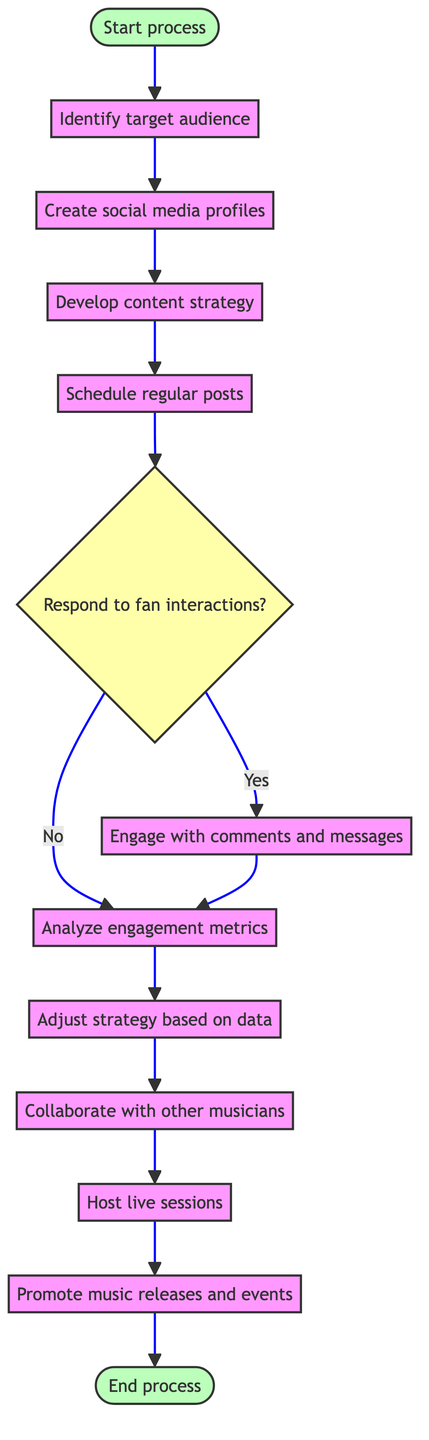What is the first action in the diagram? The first action after the start node is "Identify target audience," which is the immediate next step outlined in the process.
Answer: Identify target audience How many actions are present in the diagram? To find the number of actions, we can count all the listed actions before reaching the decision node and beyond. There are eight actions total: Identify target audience, Create social media profiles, Develop content strategy, Schedule regular posts, Engage with comments and messages, Analyze engagement metrics, Adjust strategy based on data, and Collaborate with other musicians, Host live sessions, and Promote music releases and events
Answer: Eight What happens if the response to fan interactions is 'No'? If the response to fan interactions is 'No,' the next action taken will be to analyze engagement metrics, as indicated by the flow of the diagram after making that decision.
Answer: Analyze engagement metrics Which action follows 'Analyze engagement metrics'? After analyzing the engagement metrics, the next action is to adjust the strategy based on data to improve growth and engagement.
Answer: Adjust strategy based on data What type of action is 'Respond to fan interactions'? This element is a decision point that determines whether to engage with fans based on their interactions. It acts as a critical junction in the process, guiding what happens next depending on the response.
Answer: Decision How many different actions lead to 'Promote music releases and events'? There is only one direct action that leads to 'Promote music releases and events,' which is 'Host live sessions.' Therefore, we can conclude that only one action influences this step directly.
Answer: One What is the terminal point of the diagram? The process concludes at the 'End process' node, which signifies that all actions and decisions have been completed in the flow.
Answer: End process What do you do after scheduling regular posts? Following the scheduling of regular posts, the next step is to respond to fan interactions, depending on whether interaction is needed or not based on the decision made.
Answer: Respond to fan interactions 